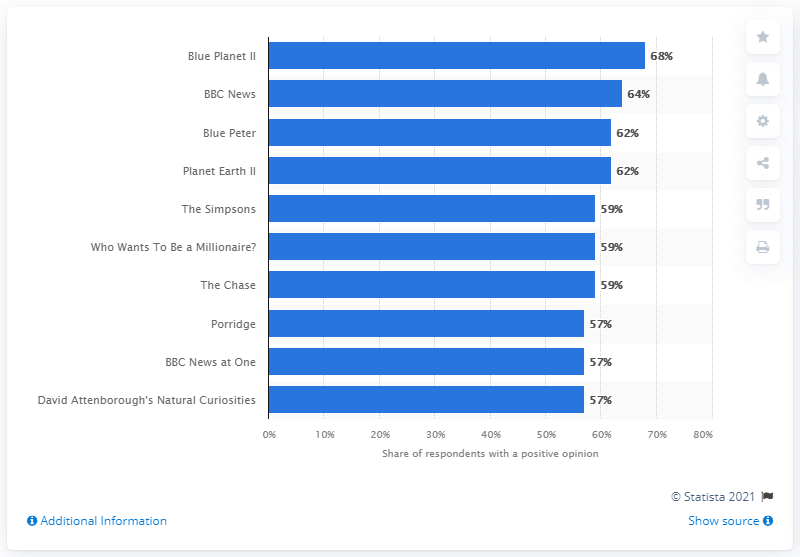Which program has an equal rating to 'Planet Earth II'? 'Blue Peter' has an equal rating to 'Planet Earth II', both receiving a 62% share of respondents with a positive opinion according to the data shown. 